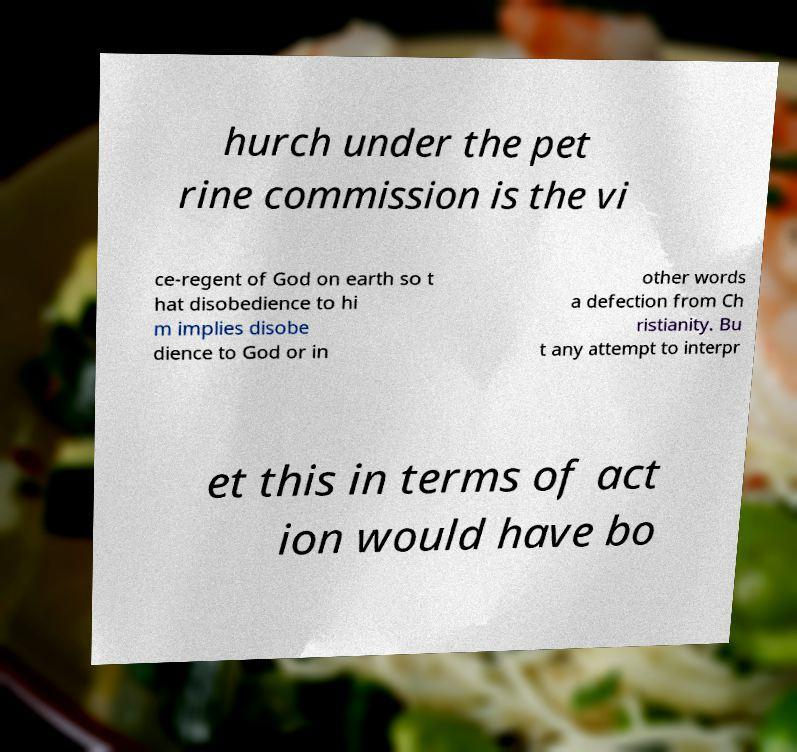Please identify and transcribe the text found in this image. hurch under the pet rine commission is the vi ce-regent of God on earth so t hat disobedience to hi m implies disobe dience to God or in other words a defection from Ch ristianity. Bu t any attempt to interpr et this in terms of act ion would have bo 